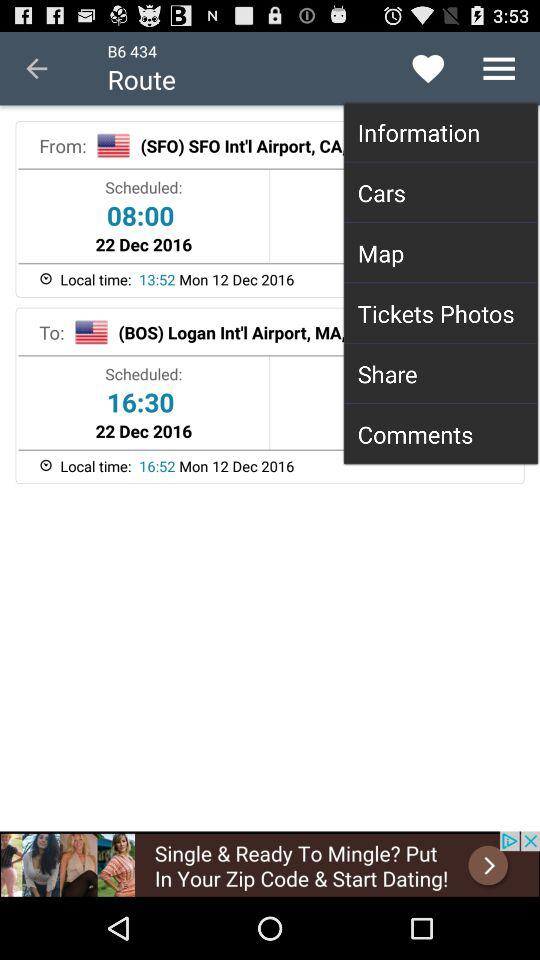What is the start location?
When the provided information is insufficient, respond with <no answer>. <no answer> 